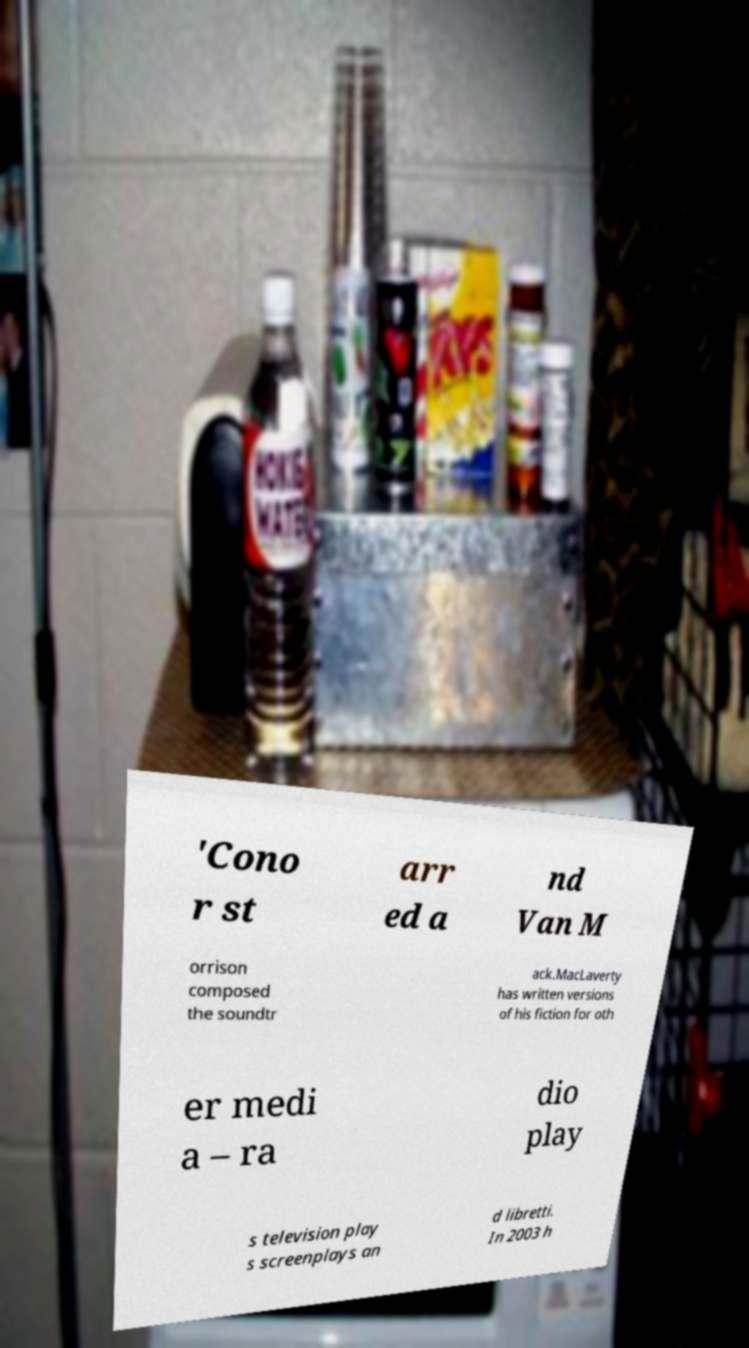Please read and relay the text visible in this image. What does it say? 'Cono r st arr ed a nd Van M orrison composed the soundtr ack.MacLaverty has written versions of his fiction for oth er medi a – ra dio play s television play s screenplays an d libretti. In 2003 h 